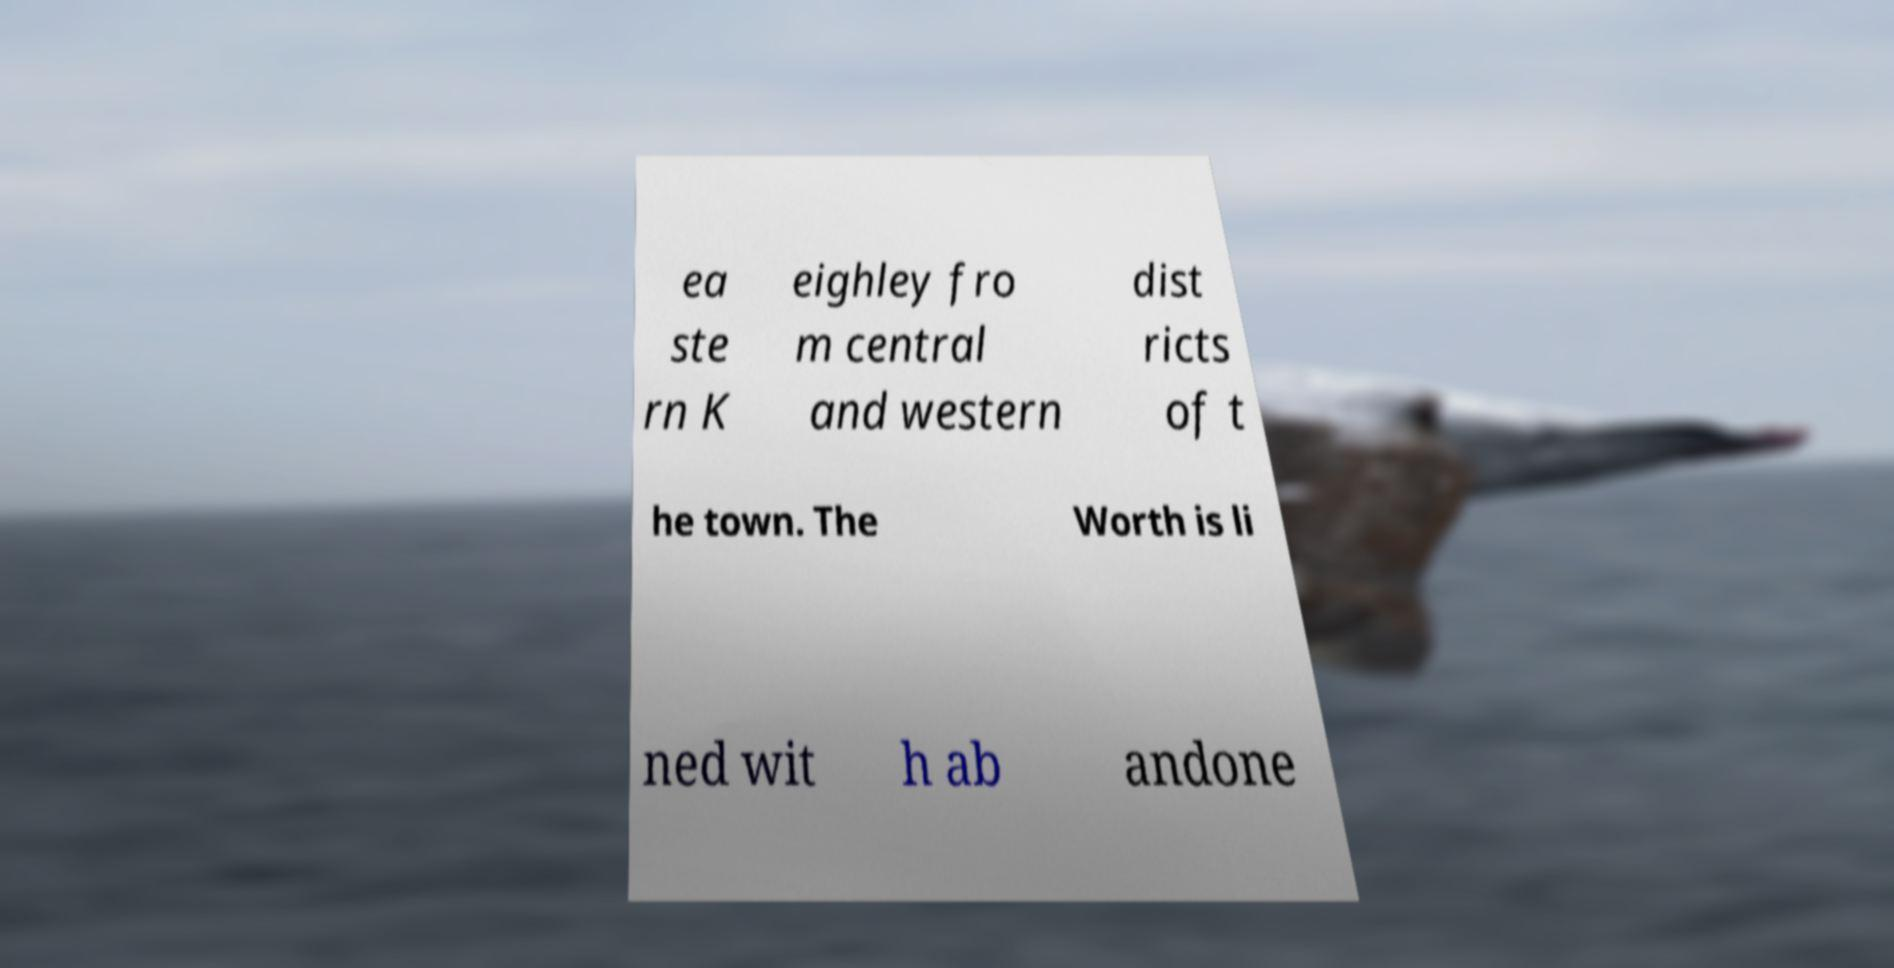Can you read and provide the text displayed in the image?This photo seems to have some interesting text. Can you extract and type it out for me? ea ste rn K eighley fro m central and western dist ricts of t he town. The Worth is li ned wit h ab andone 